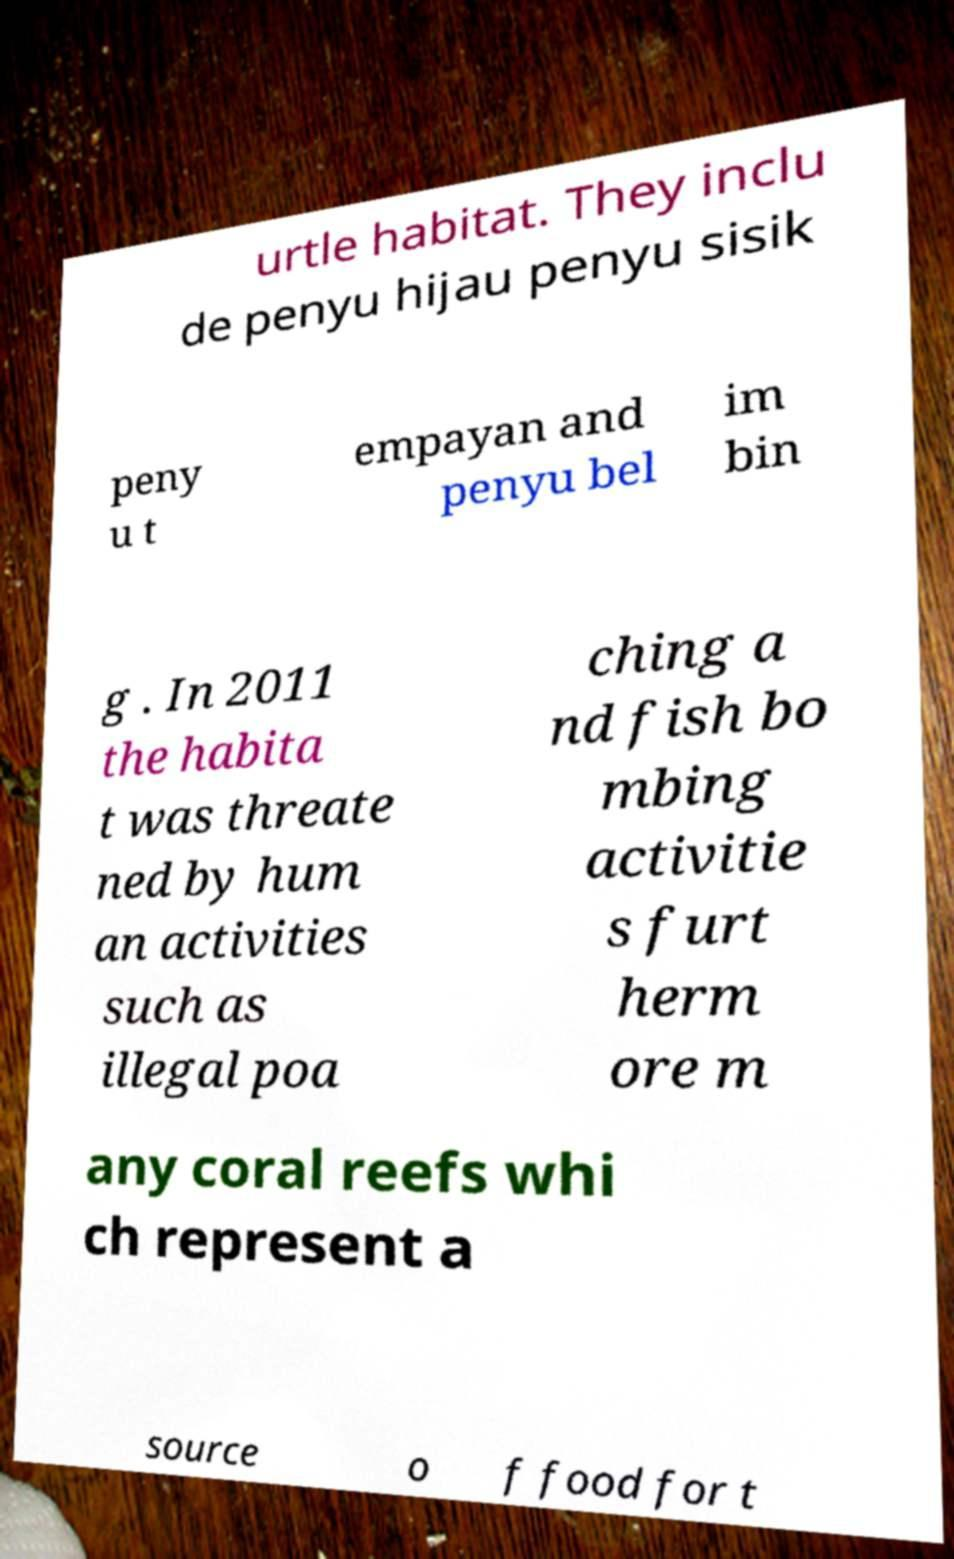Can you accurately transcribe the text from the provided image for me? urtle habitat. They inclu de penyu hijau penyu sisik peny u t empayan and penyu bel im bin g . In 2011 the habita t was threate ned by hum an activities such as illegal poa ching a nd fish bo mbing activitie s furt herm ore m any coral reefs whi ch represent a source o f food for t 